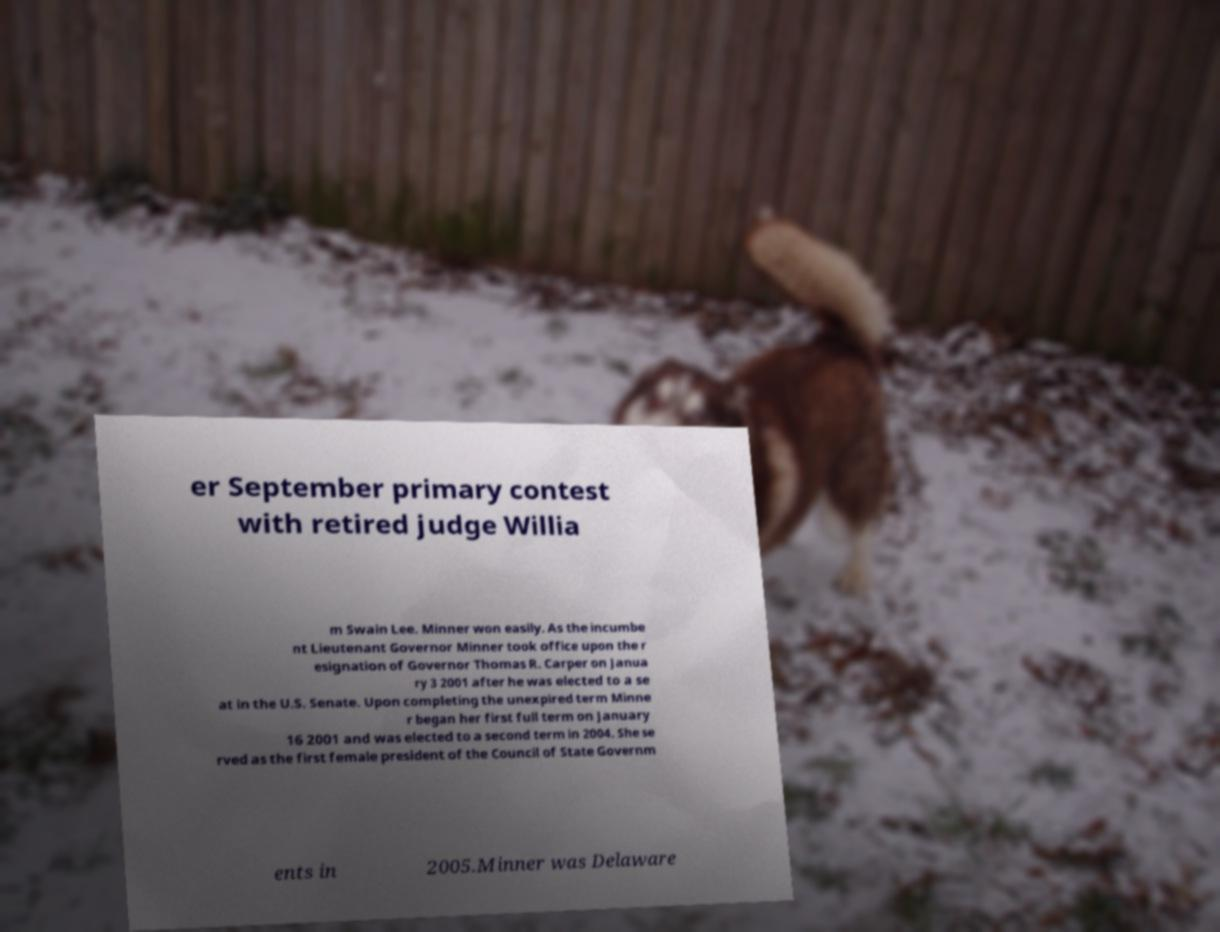Could you extract and type out the text from this image? er September primary contest with retired judge Willia m Swain Lee. Minner won easily. As the incumbe nt Lieutenant Governor Minner took office upon the r esignation of Governor Thomas R. Carper on Janua ry 3 2001 after he was elected to a se at in the U.S. Senate. Upon completing the unexpired term Minne r began her first full term on January 16 2001 and was elected to a second term in 2004. She se rved as the first female president of the Council of State Governm ents in 2005.Minner was Delaware 